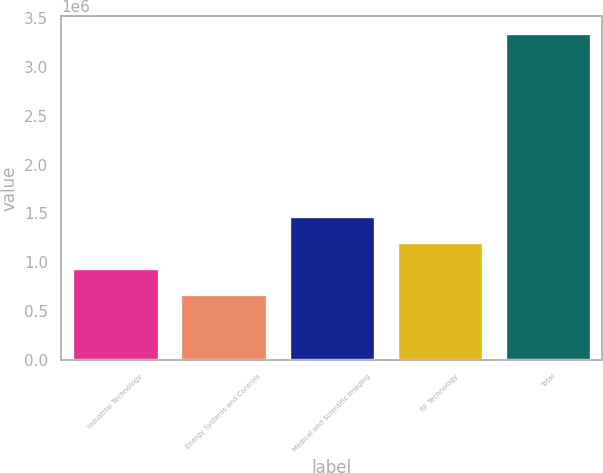Convert chart to OTSL. <chart><loc_0><loc_0><loc_500><loc_500><bar_chart><fcel>Industrial Technology<fcel>Energy Systems and Controls<fcel>Medical and Scientific Imaging<fcel>RF Technology<fcel>Total<nl><fcel>941061<fcel>673569<fcel>1.47605e+06<fcel>1.20855e+06<fcel>3.34849e+06<nl></chart> 